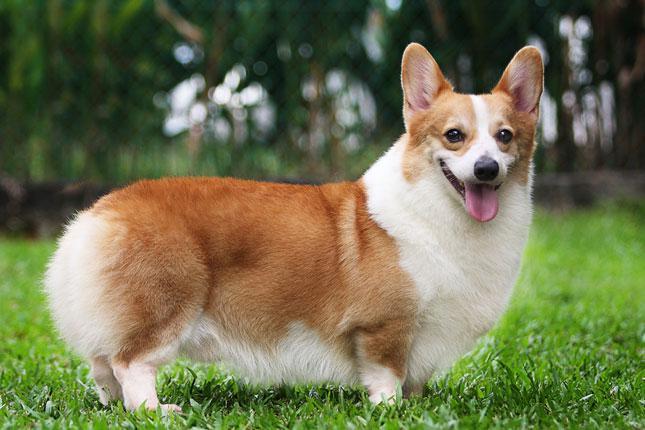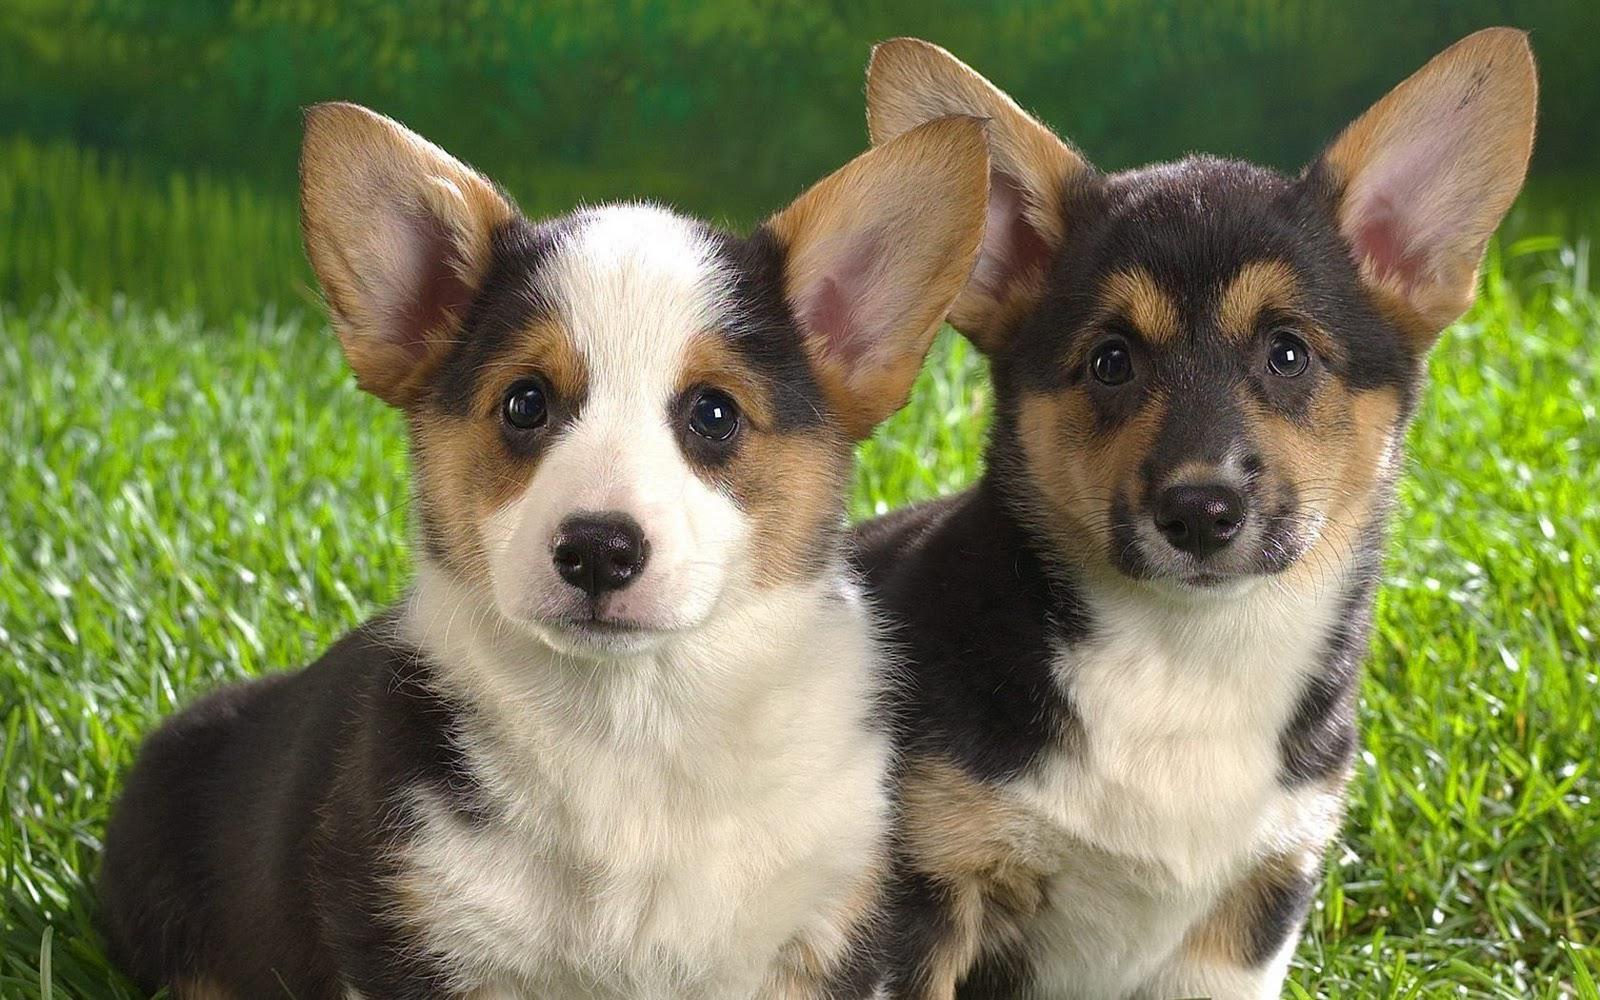The first image is the image on the left, the second image is the image on the right. Evaluate the accuracy of this statement regarding the images: "There are at least three Corgis in the image.". Is it true? Answer yes or no. Yes. The first image is the image on the left, the second image is the image on the right. Assess this claim about the two images: "one dog facing body pointed left in the left pic". Correct or not? Answer yes or no. No. 